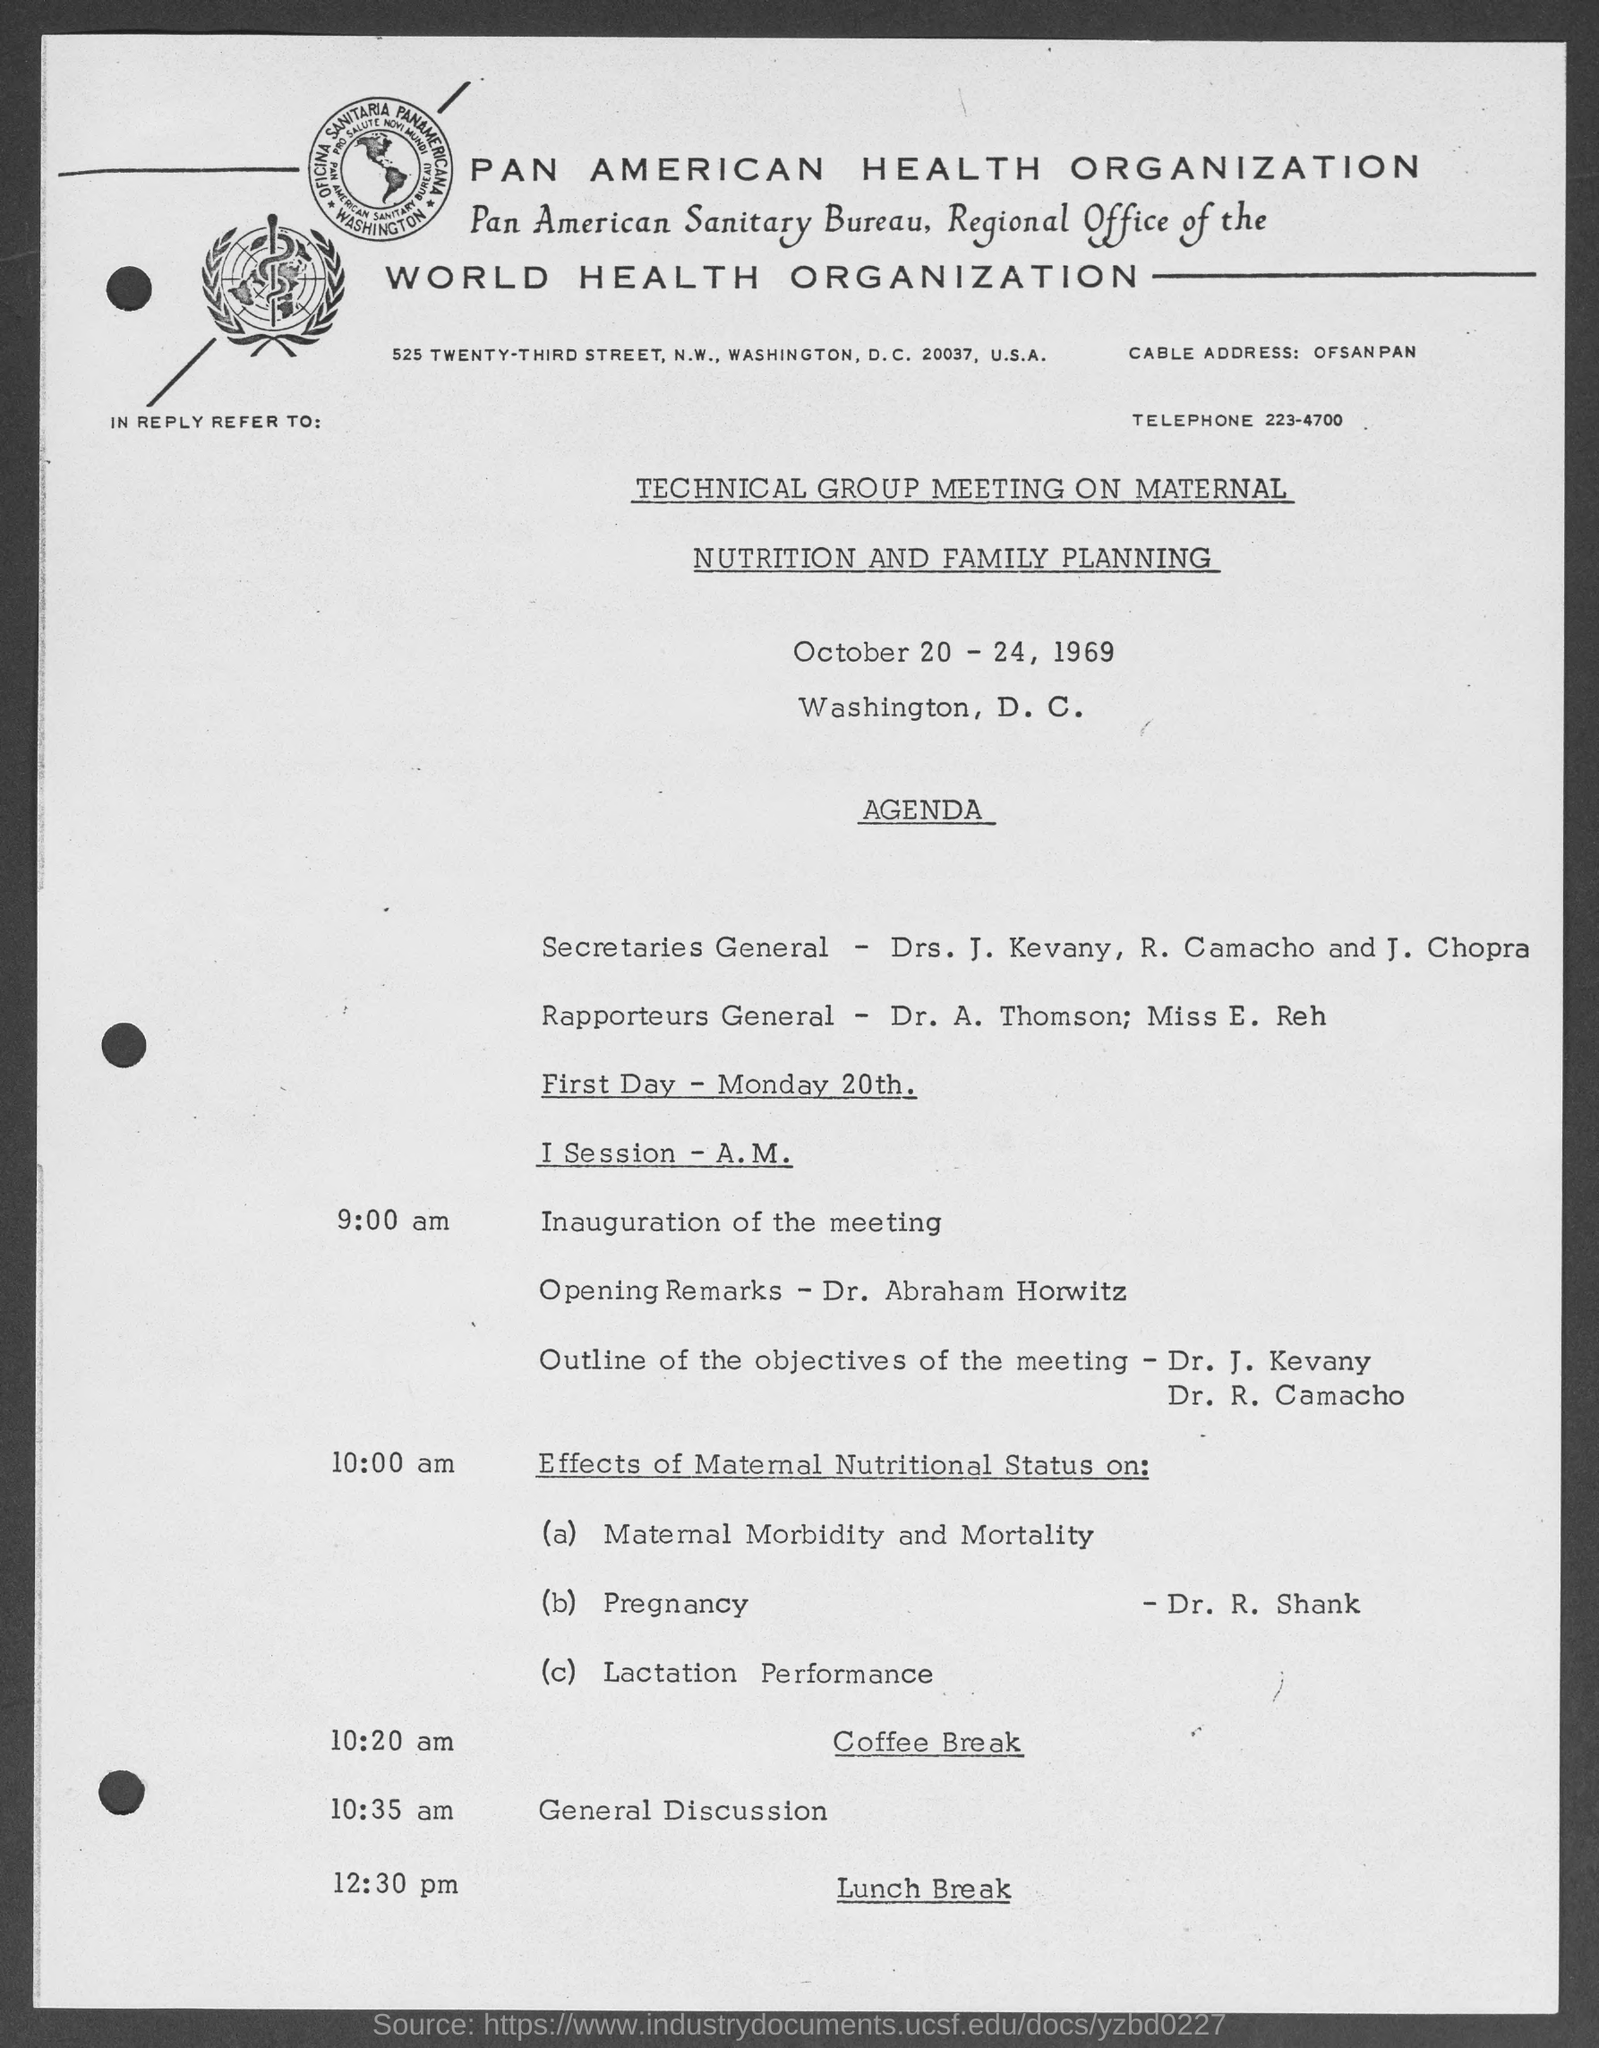Indicate a few pertinent items in this graphic. The telephone number provided is 223-4700. The Rapporteurs General are Dr. A. Thomson and Miss E. Reh. On the first day, which is Monday 20th, Dr. Abraham Horwitz will deliver the opening remarks. 